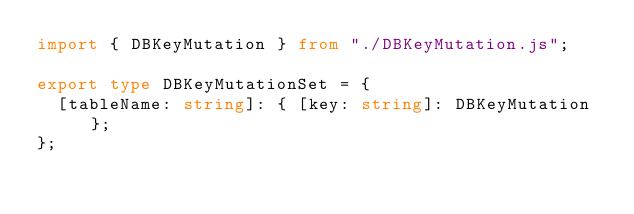<code> <loc_0><loc_0><loc_500><loc_500><_TypeScript_>import { DBKeyMutation } from "./DBKeyMutation.js";

export type DBKeyMutationSet = {
  [tableName: string]: { [key: string]: DBKeyMutation };
};
</code> 